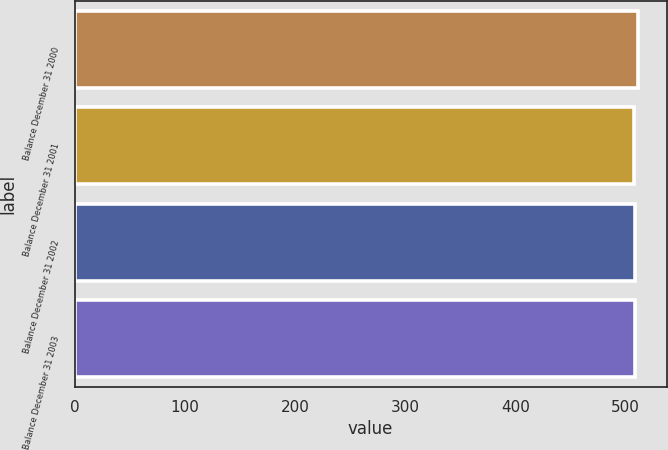Convert chart. <chart><loc_0><loc_0><loc_500><loc_500><bar_chart><fcel>Balance December 31 2000<fcel>Balance December 31 2001<fcel>Balance December 31 2002<fcel>Balance December 31 2003<nl><fcel>511.4<fcel>507.6<fcel>507.98<fcel>508.36<nl></chart> 